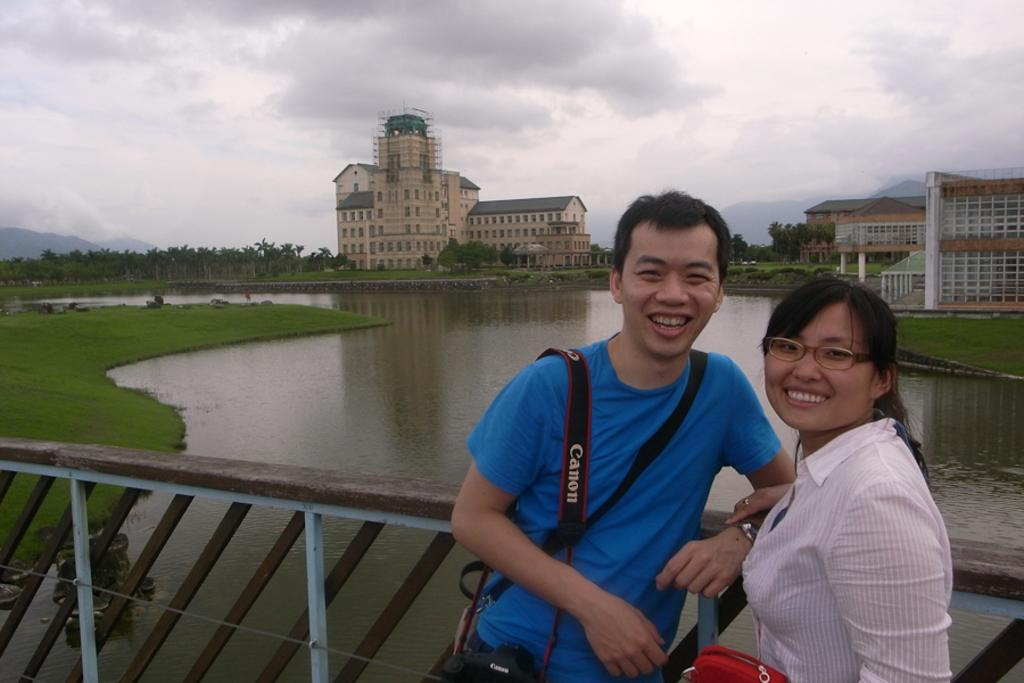Provide a one-sentence caption for the provided image. Couple posing for a picture with the guy wearing a strap that says Canon. 